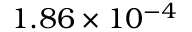<formula> <loc_0><loc_0><loc_500><loc_500>1 . 8 6 \times 1 0 ^ { - 4 }</formula> 